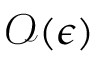Convert formula to latex. <formula><loc_0><loc_0><loc_500><loc_500>\mathcal { O } ( \epsilon )</formula> 